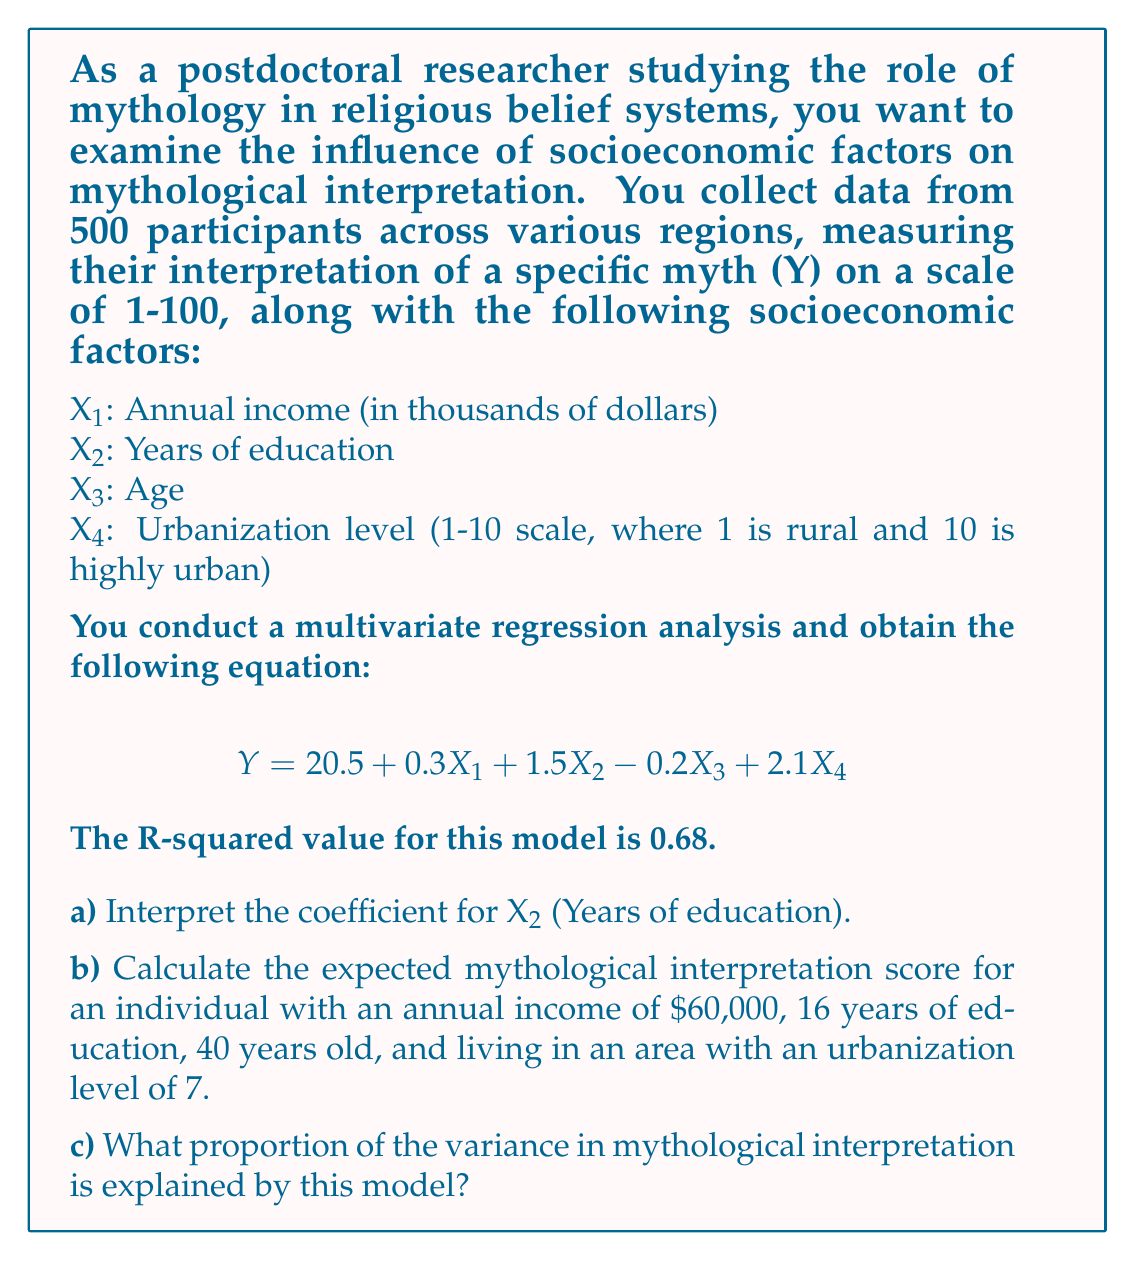Give your solution to this math problem. Let's break this down step by step:

a) Interpreting the coefficient for X2 (Years of education):
The coefficient for X2 is 1.5. This means that for each additional year of education, the mythological interpretation score is expected to increase by 1.5 points, holding all other variables constant.

b) Calculating the expected mythological interpretation score:
We'll use the regression equation and plug in the given values:

$$ Y = 20.5 + 0.3X_1 + 1.5X_2 - 0.2X_3 + 2.1X_4 $$

Where:
X1 = 60 (annual income in thousands)
X2 = 16 (years of education)
X3 = 40 (age)
X4 = 7 (urbanization level)

Plugging in these values:

$$ Y = 20.5 + 0.3(60) + 1.5(16) - 0.2(40) + 2.1(7) $$
$$ Y = 20.5 + 18 + 24 - 8 + 14.7 $$
$$ Y = 69.2 $$

c) Proportion of variance explained by the model:
The R-squared value represents the proportion of the variance in the dependent variable (Y) that is predictable from the independent variables (X1, X2, X3, X4). The R-squared value is given as 0.68, which means that 68% of the variance in mythological interpretation is explained by this model.
Answer: a) For each additional year of education, the mythological interpretation score is expected to increase by 1.5 points, holding all other variables constant.

b) The expected mythological interpretation score for the given individual is 69.2.

c) 68% of the variance in mythological interpretation is explained by this model. 